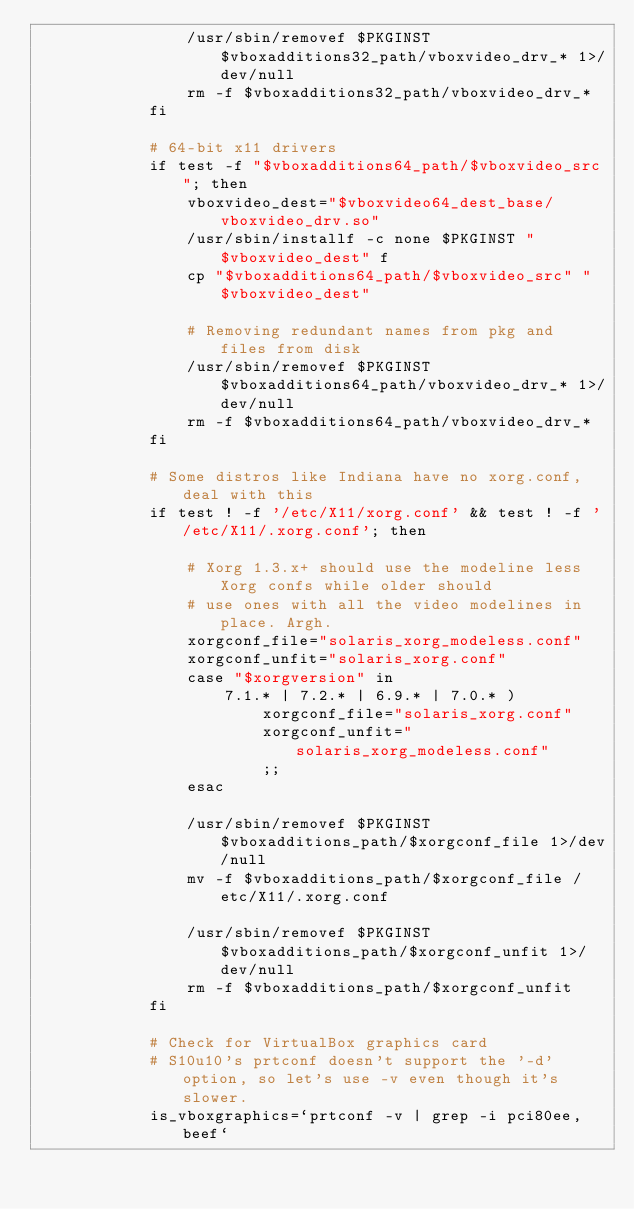Convert code to text. <code><loc_0><loc_0><loc_500><loc_500><_Bash_>                /usr/sbin/removef $PKGINST $vboxadditions32_path/vboxvideo_drv_* 1>/dev/null
                rm -f $vboxadditions32_path/vboxvideo_drv_*
            fi

            # 64-bit x11 drivers
            if test -f "$vboxadditions64_path/$vboxvideo_src"; then
                vboxvideo_dest="$vboxvideo64_dest_base/vboxvideo_drv.so"
                /usr/sbin/installf -c none $PKGINST "$vboxvideo_dest" f
                cp "$vboxadditions64_path/$vboxvideo_src" "$vboxvideo_dest"

                # Removing redundant names from pkg and files from disk
                /usr/sbin/removef $PKGINST $vboxadditions64_path/vboxvideo_drv_* 1>/dev/null
                rm -f $vboxadditions64_path/vboxvideo_drv_*
            fi

            # Some distros like Indiana have no xorg.conf, deal with this
            if test ! -f '/etc/X11/xorg.conf' && test ! -f '/etc/X11/.xorg.conf'; then

                # Xorg 1.3.x+ should use the modeline less Xorg confs while older should
                # use ones with all the video modelines in place. Argh.
                xorgconf_file="solaris_xorg_modeless.conf"
                xorgconf_unfit="solaris_xorg.conf"
                case "$xorgversion" in
                    7.1.* | 7.2.* | 6.9.* | 7.0.* )
                        xorgconf_file="solaris_xorg.conf"
                        xorgconf_unfit="solaris_xorg_modeless.conf"
                        ;;
                esac

                /usr/sbin/removef $PKGINST $vboxadditions_path/$xorgconf_file 1>/dev/null
                mv -f $vboxadditions_path/$xorgconf_file /etc/X11/.xorg.conf

                /usr/sbin/removef $PKGINST $vboxadditions_path/$xorgconf_unfit 1>/dev/null
                rm -f $vboxadditions_path/$xorgconf_unfit
            fi

            # Check for VirtualBox graphics card
            # S10u10's prtconf doesn't support the '-d' option, so let's use -v even though it's slower.
            is_vboxgraphics=`prtconf -v | grep -i pci80ee,beef`</code> 